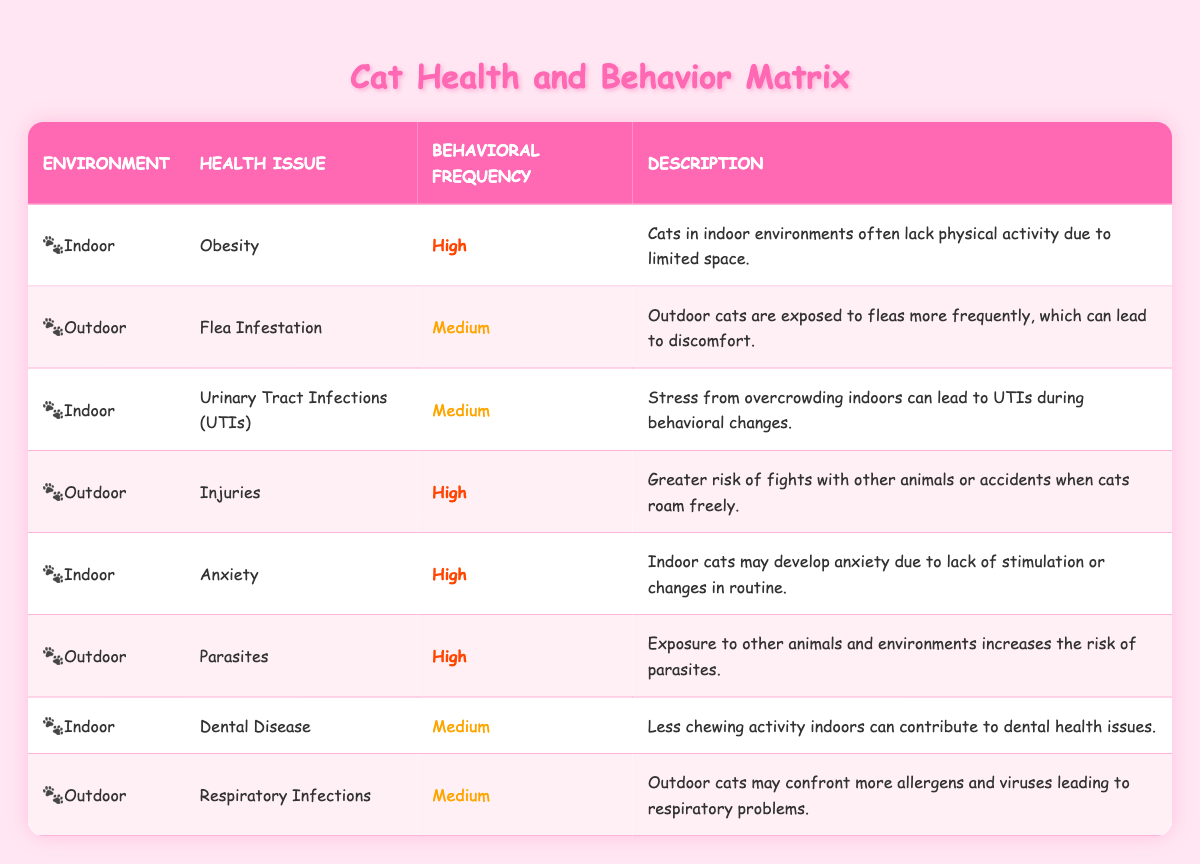What health issue is reported at a high frequency for indoor cats? According to the table, the health issues reported with high frequency for indoor cats are Obesity and Anxiety. These are specifically noted in the rows for the Indoor environment.
Answer: Obesity and Anxiety What is the behavioral frequency of flea infestation in outdoor cats? The table indicates that flea infestation in outdoor cats has a medium behavioral frequency. This information is found in the corresponding row for the outdoor environment and flea infestation health issue.
Answer: Medium Are indoor cats at high risk for urinary tract infections? Yes, the table shows that urinary tract infections (UTIs) are categorized with a medium behavioral frequency for indoor cats, suggesting that while it is a health concern, it isn't at a high frequency compared to other issues.
Answer: Yes How many health issues are reported as high frequency for outdoor cats? There are three health issues reported as high frequency for outdoor cats: Injuries, Parasites, and Flea Infestation. This information is gathered by counting the rows that mention the Outdoor environment with a high frequency status.
Answer: Three What is the difference in behavioral frequency between dental disease for indoor cats and respiratory infections for outdoor cats? Dental disease for indoor cats is classified as medium frequency, while respiratory infections for outdoor cats are also classified as medium frequency. Thus, the difference in frequency is zero; both are at the same level of medium.
Answer: Zero What percentage of health issues listed for indoor cats have a high frequency? There are four health issues reported for indoor cats: Obesity, Urinary Tract Infections (UTIs), Anxiety, and Dental Disease. Out of these, two (Obesity and Anxiety) are high frequency. Thus, the percentage is calculated as (2/4) * 100 = 50%.
Answer: 50% Is it true that all health issues listed for outdoor cats have a high frequency? No, the data shows that not all health issues for outdoor cats are classified as high frequency. Flea Infestation and Respiratory Infections have a medium frequency, indicating that this statement is false.
Answer: No Which health issue has the highest behavioral frequency for indoor environments? The table specifically mentions two health issues with high frequency for indoor cats: Obesity and Anxiety. Both are categorized with the highest frequency, indicating they are major concerns in indoor environments.
Answer: Obesity and Anxiety 